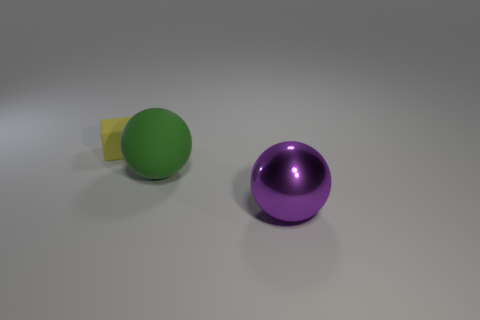Add 1 tiny red things. How many objects exist? 4 Subtract all cubes. How many objects are left? 2 Subtract all yellow things. Subtract all matte objects. How many objects are left? 0 Add 1 cubes. How many cubes are left? 2 Add 2 tiny yellow matte things. How many tiny yellow matte things exist? 3 Subtract 0 gray cubes. How many objects are left? 3 